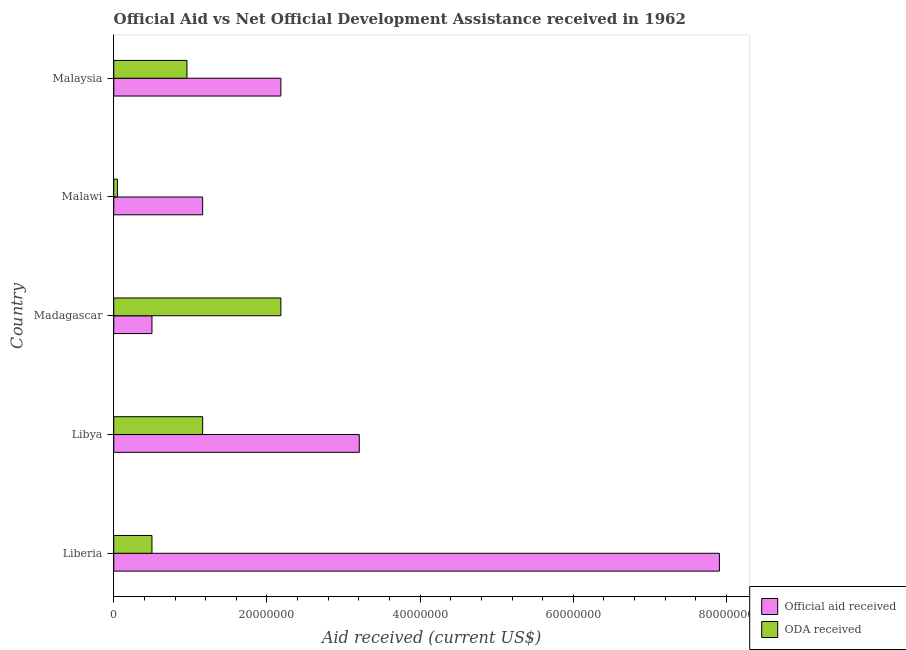How many groups of bars are there?
Make the answer very short. 5. What is the label of the 2nd group of bars from the top?
Provide a succinct answer. Malawi. In how many cases, is the number of bars for a given country not equal to the number of legend labels?
Ensure brevity in your answer.  0. What is the official aid received in Malaysia?
Your answer should be compact. 2.18e+07. Across all countries, what is the maximum official aid received?
Provide a succinct answer. 7.91e+07. Across all countries, what is the minimum oda received?
Your response must be concise. 4.80e+05. In which country was the oda received maximum?
Offer a terse response. Madagascar. In which country was the official aid received minimum?
Make the answer very short. Madagascar. What is the total official aid received in the graph?
Keep it short and to the point. 1.50e+08. What is the difference between the official aid received in Liberia and that in Madagascar?
Make the answer very short. 7.41e+07. What is the difference between the oda received in Madagascar and the official aid received in Liberia?
Offer a terse response. -5.73e+07. What is the average official aid received per country?
Give a very brief answer. 2.99e+07. What is the difference between the official aid received and oda received in Madagascar?
Provide a short and direct response. -1.68e+07. What is the ratio of the official aid received in Liberia to that in Malawi?
Offer a very short reply. 6.81. Is the oda received in Libya less than that in Madagascar?
Offer a very short reply. Yes. Is the difference between the oda received in Liberia and Malaysia greater than the difference between the official aid received in Liberia and Malaysia?
Keep it short and to the point. No. What is the difference between the highest and the second highest official aid received?
Provide a succinct answer. 4.70e+07. What is the difference between the highest and the lowest official aid received?
Your answer should be compact. 7.41e+07. In how many countries, is the official aid received greater than the average official aid received taken over all countries?
Your answer should be compact. 2. What does the 1st bar from the top in Libya represents?
Keep it short and to the point. ODA received. What does the 1st bar from the bottom in Malaysia represents?
Ensure brevity in your answer.  Official aid received. How many bars are there?
Keep it short and to the point. 10. What is the difference between two consecutive major ticks on the X-axis?
Your response must be concise. 2.00e+07. Does the graph contain any zero values?
Make the answer very short. No. How many legend labels are there?
Offer a terse response. 2. What is the title of the graph?
Your response must be concise. Official Aid vs Net Official Development Assistance received in 1962 . Does "Male labor force" appear as one of the legend labels in the graph?
Your response must be concise. No. What is the label or title of the X-axis?
Offer a terse response. Aid received (current US$). What is the label or title of the Y-axis?
Your answer should be very brief. Country. What is the Aid received (current US$) in Official aid received in Liberia?
Provide a short and direct response. 7.91e+07. What is the Aid received (current US$) in ODA received in Liberia?
Give a very brief answer. 4.99e+06. What is the Aid received (current US$) in Official aid received in Libya?
Offer a terse response. 3.21e+07. What is the Aid received (current US$) of ODA received in Libya?
Keep it short and to the point. 1.16e+07. What is the Aid received (current US$) of Official aid received in Madagascar?
Give a very brief answer. 4.99e+06. What is the Aid received (current US$) in ODA received in Madagascar?
Offer a very short reply. 2.18e+07. What is the Aid received (current US$) of Official aid received in Malawi?
Make the answer very short. 1.16e+07. What is the Aid received (current US$) of Official aid received in Malaysia?
Your answer should be compact. 2.18e+07. What is the Aid received (current US$) in ODA received in Malaysia?
Your response must be concise. 9.56e+06. Across all countries, what is the maximum Aid received (current US$) of Official aid received?
Make the answer very short. 7.91e+07. Across all countries, what is the maximum Aid received (current US$) in ODA received?
Your response must be concise. 2.18e+07. Across all countries, what is the minimum Aid received (current US$) of Official aid received?
Your response must be concise. 4.99e+06. What is the total Aid received (current US$) of Official aid received in the graph?
Provide a succinct answer. 1.50e+08. What is the total Aid received (current US$) in ODA received in the graph?
Give a very brief answer. 4.85e+07. What is the difference between the Aid received (current US$) in Official aid received in Liberia and that in Libya?
Offer a very short reply. 4.70e+07. What is the difference between the Aid received (current US$) of ODA received in Liberia and that in Libya?
Offer a very short reply. -6.62e+06. What is the difference between the Aid received (current US$) in Official aid received in Liberia and that in Madagascar?
Offer a very short reply. 7.41e+07. What is the difference between the Aid received (current US$) in ODA received in Liberia and that in Madagascar?
Give a very brief answer. -1.68e+07. What is the difference between the Aid received (current US$) of Official aid received in Liberia and that in Malawi?
Your answer should be very brief. 6.75e+07. What is the difference between the Aid received (current US$) of ODA received in Liberia and that in Malawi?
Provide a succinct answer. 4.51e+06. What is the difference between the Aid received (current US$) in Official aid received in Liberia and that in Malaysia?
Offer a very short reply. 5.73e+07. What is the difference between the Aid received (current US$) in ODA received in Liberia and that in Malaysia?
Your answer should be very brief. -4.57e+06. What is the difference between the Aid received (current US$) in Official aid received in Libya and that in Madagascar?
Provide a short and direct response. 2.71e+07. What is the difference between the Aid received (current US$) of ODA received in Libya and that in Madagascar?
Provide a short and direct response. -1.02e+07. What is the difference between the Aid received (current US$) of Official aid received in Libya and that in Malawi?
Ensure brevity in your answer.  2.04e+07. What is the difference between the Aid received (current US$) of ODA received in Libya and that in Malawi?
Give a very brief answer. 1.11e+07. What is the difference between the Aid received (current US$) of Official aid received in Libya and that in Malaysia?
Provide a short and direct response. 1.02e+07. What is the difference between the Aid received (current US$) in ODA received in Libya and that in Malaysia?
Give a very brief answer. 2.05e+06. What is the difference between the Aid received (current US$) in Official aid received in Madagascar and that in Malawi?
Give a very brief answer. -6.62e+06. What is the difference between the Aid received (current US$) of ODA received in Madagascar and that in Malawi?
Provide a succinct answer. 2.13e+07. What is the difference between the Aid received (current US$) in Official aid received in Madagascar and that in Malaysia?
Make the answer very short. -1.68e+07. What is the difference between the Aid received (current US$) of ODA received in Madagascar and that in Malaysia?
Offer a terse response. 1.23e+07. What is the difference between the Aid received (current US$) in Official aid received in Malawi and that in Malaysia?
Keep it short and to the point. -1.02e+07. What is the difference between the Aid received (current US$) in ODA received in Malawi and that in Malaysia?
Your answer should be very brief. -9.08e+06. What is the difference between the Aid received (current US$) in Official aid received in Liberia and the Aid received (current US$) in ODA received in Libya?
Offer a very short reply. 6.75e+07. What is the difference between the Aid received (current US$) in Official aid received in Liberia and the Aid received (current US$) in ODA received in Madagascar?
Your answer should be compact. 5.73e+07. What is the difference between the Aid received (current US$) of Official aid received in Liberia and the Aid received (current US$) of ODA received in Malawi?
Give a very brief answer. 7.86e+07. What is the difference between the Aid received (current US$) in Official aid received in Liberia and the Aid received (current US$) in ODA received in Malaysia?
Make the answer very short. 6.95e+07. What is the difference between the Aid received (current US$) in Official aid received in Libya and the Aid received (current US$) in ODA received in Madagascar?
Provide a succinct answer. 1.02e+07. What is the difference between the Aid received (current US$) in Official aid received in Libya and the Aid received (current US$) in ODA received in Malawi?
Make the answer very short. 3.16e+07. What is the difference between the Aid received (current US$) of Official aid received in Libya and the Aid received (current US$) of ODA received in Malaysia?
Offer a very short reply. 2.25e+07. What is the difference between the Aid received (current US$) in Official aid received in Madagascar and the Aid received (current US$) in ODA received in Malawi?
Offer a terse response. 4.51e+06. What is the difference between the Aid received (current US$) of Official aid received in Madagascar and the Aid received (current US$) of ODA received in Malaysia?
Keep it short and to the point. -4.57e+06. What is the difference between the Aid received (current US$) of Official aid received in Malawi and the Aid received (current US$) of ODA received in Malaysia?
Your response must be concise. 2.05e+06. What is the average Aid received (current US$) of Official aid received per country?
Provide a short and direct response. 2.99e+07. What is the average Aid received (current US$) in ODA received per country?
Provide a short and direct response. 9.69e+06. What is the difference between the Aid received (current US$) of Official aid received and Aid received (current US$) of ODA received in Liberia?
Ensure brevity in your answer.  7.41e+07. What is the difference between the Aid received (current US$) in Official aid received and Aid received (current US$) in ODA received in Libya?
Your answer should be very brief. 2.04e+07. What is the difference between the Aid received (current US$) of Official aid received and Aid received (current US$) of ODA received in Madagascar?
Your response must be concise. -1.68e+07. What is the difference between the Aid received (current US$) of Official aid received and Aid received (current US$) of ODA received in Malawi?
Your response must be concise. 1.11e+07. What is the difference between the Aid received (current US$) of Official aid received and Aid received (current US$) of ODA received in Malaysia?
Keep it short and to the point. 1.23e+07. What is the ratio of the Aid received (current US$) in Official aid received in Liberia to that in Libya?
Offer a terse response. 2.47. What is the ratio of the Aid received (current US$) in ODA received in Liberia to that in Libya?
Make the answer very short. 0.43. What is the ratio of the Aid received (current US$) of Official aid received in Liberia to that in Madagascar?
Provide a succinct answer. 15.85. What is the ratio of the Aid received (current US$) of ODA received in Liberia to that in Madagascar?
Provide a short and direct response. 0.23. What is the ratio of the Aid received (current US$) of Official aid received in Liberia to that in Malawi?
Your response must be concise. 6.81. What is the ratio of the Aid received (current US$) in ODA received in Liberia to that in Malawi?
Provide a succinct answer. 10.4. What is the ratio of the Aid received (current US$) of Official aid received in Liberia to that in Malaysia?
Give a very brief answer. 3.62. What is the ratio of the Aid received (current US$) of ODA received in Liberia to that in Malaysia?
Ensure brevity in your answer.  0.52. What is the ratio of the Aid received (current US$) in Official aid received in Libya to that in Madagascar?
Make the answer very short. 6.42. What is the ratio of the Aid received (current US$) in ODA received in Libya to that in Madagascar?
Give a very brief answer. 0.53. What is the ratio of the Aid received (current US$) of Official aid received in Libya to that in Malawi?
Provide a succinct answer. 2.76. What is the ratio of the Aid received (current US$) of ODA received in Libya to that in Malawi?
Your response must be concise. 24.19. What is the ratio of the Aid received (current US$) of Official aid received in Libya to that in Malaysia?
Your response must be concise. 1.47. What is the ratio of the Aid received (current US$) in ODA received in Libya to that in Malaysia?
Provide a short and direct response. 1.21. What is the ratio of the Aid received (current US$) of Official aid received in Madagascar to that in Malawi?
Your answer should be very brief. 0.43. What is the ratio of the Aid received (current US$) of ODA received in Madagascar to that in Malawi?
Keep it short and to the point. 45.46. What is the ratio of the Aid received (current US$) in Official aid received in Madagascar to that in Malaysia?
Your response must be concise. 0.23. What is the ratio of the Aid received (current US$) in ODA received in Madagascar to that in Malaysia?
Offer a very short reply. 2.28. What is the ratio of the Aid received (current US$) of Official aid received in Malawi to that in Malaysia?
Keep it short and to the point. 0.53. What is the ratio of the Aid received (current US$) of ODA received in Malawi to that in Malaysia?
Make the answer very short. 0.05. What is the difference between the highest and the second highest Aid received (current US$) of Official aid received?
Your answer should be compact. 4.70e+07. What is the difference between the highest and the second highest Aid received (current US$) of ODA received?
Make the answer very short. 1.02e+07. What is the difference between the highest and the lowest Aid received (current US$) of Official aid received?
Provide a short and direct response. 7.41e+07. What is the difference between the highest and the lowest Aid received (current US$) of ODA received?
Ensure brevity in your answer.  2.13e+07. 